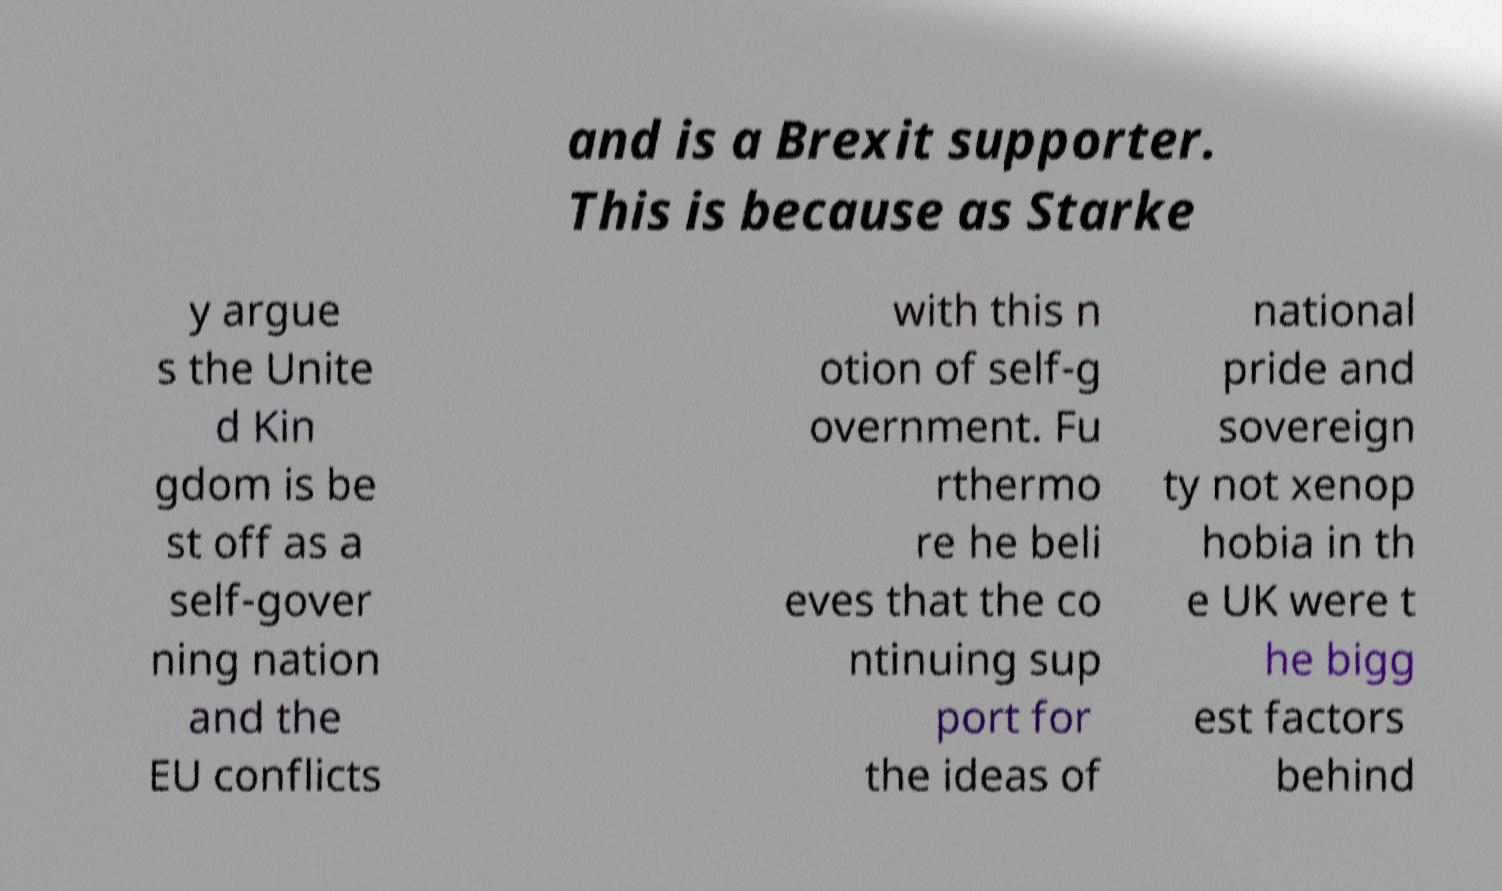I need the written content from this picture converted into text. Can you do that? and is a Brexit supporter. This is because as Starke y argue s the Unite d Kin gdom is be st off as a self-gover ning nation and the EU conflicts with this n otion of self-g overnment. Fu rthermo re he beli eves that the co ntinuing sup port for the ideas of national pride and sovereign ty not xenop hobia in th e UK were t he bigg est factors behind 